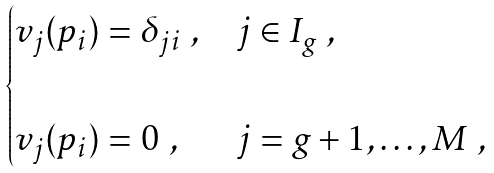Convert formula to latex. <formula><loc_0><loc_0><loc_500><loc_500>\begin{cases} v _ { j } ( p _ { i } ) = \delta _ { j i } \ , & j \in I _ { g } \ , \\ & \\ v _ { j } ( p _ { i } ) = 0 \ , & j = g + 1 , \dots , M \ , \end{cases}</formula> 